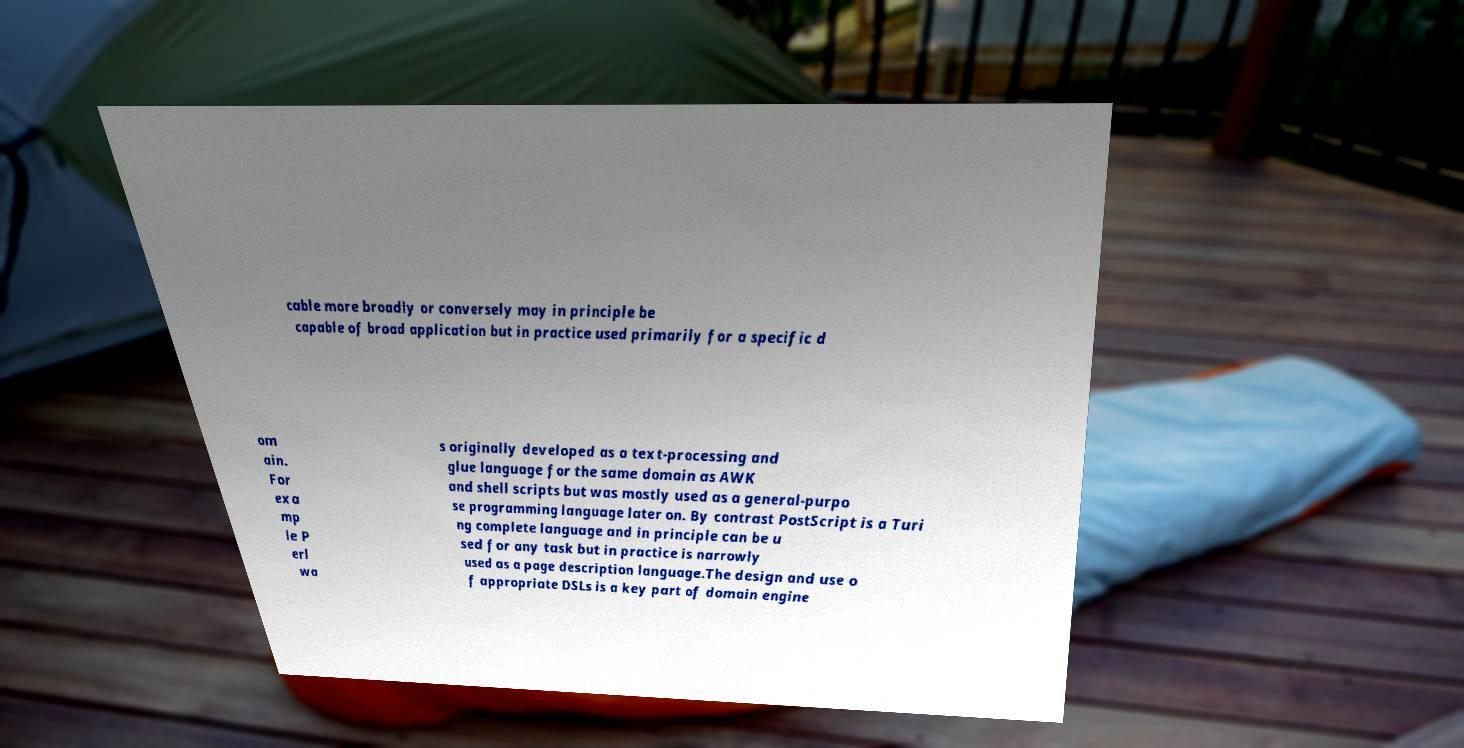Could you assist in decoding the text presented in this image and type it out clearly? cable more broadly or conversely may in principle be capable of broad application but in practice used primarily for a specific d om ain. For exa mp le P erl wa s originally developed as a text-processing and glue language for the same domain as AWK and shell scripts but was mostly used as a general-purpo se programming language later on. By contrast PostScript is a Turi ng complete language and in principle can be u sed for any task but in practice is narrowly used as a page description language.The design and use o f appropriate DSLs is a key part of domain engine 